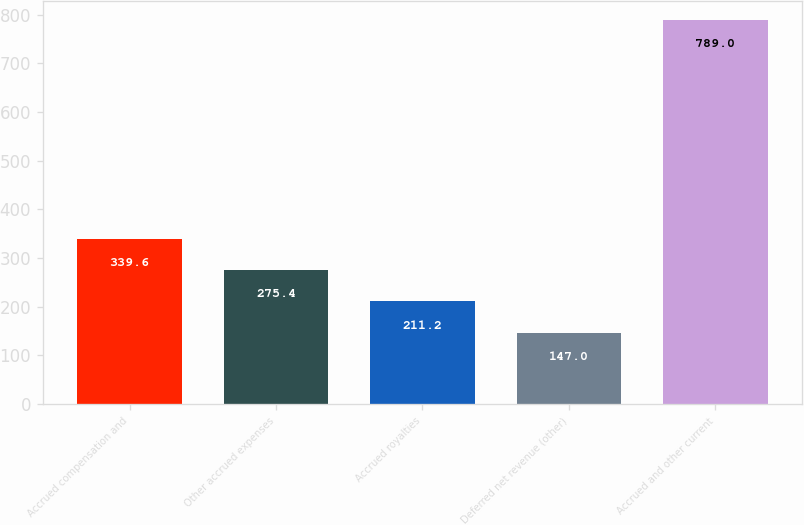Convert chart. <chart><loc_0><loc_0><loc_500><loc_500><bar_chart><fcel>Accrued compensation and<fcel>Other accrued expenses<fcel>Accrued royalties<fcel>Deferred net revenue (other)<fcel>Accrued and other current<nl><fcel>339.6<fcel>275.4<fcel>211.2<fcel>147<fcel>789<nl></chart> 